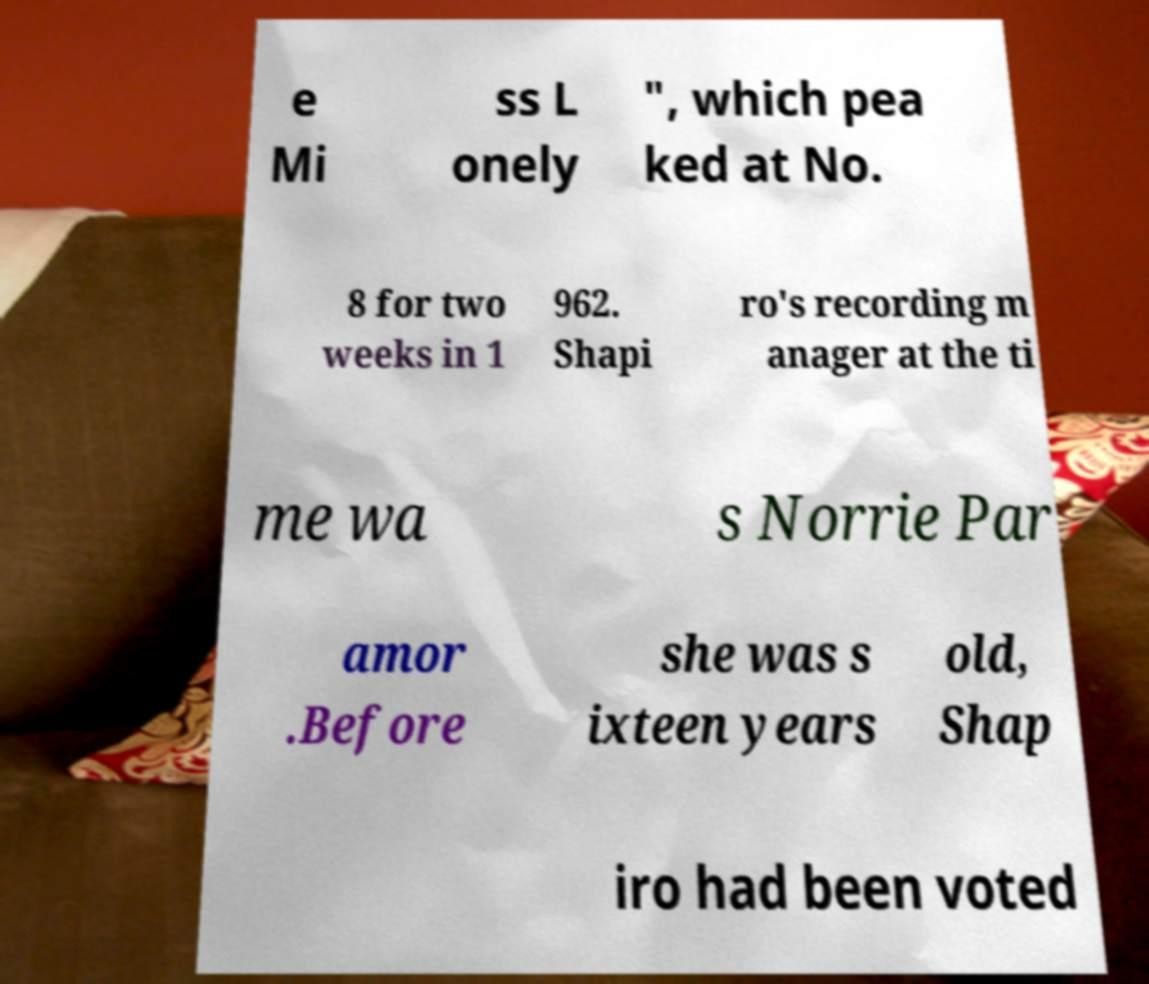Please read and relay the text visible in this image. What does it say? e Mi ss L onely ", which pea ked at No. 8 for two weeks in 1 962. Shapi ro's recording m anager at the ti me wa s Norrie Par amor .Before she was s ixteen years old, Shap iro had been voted 